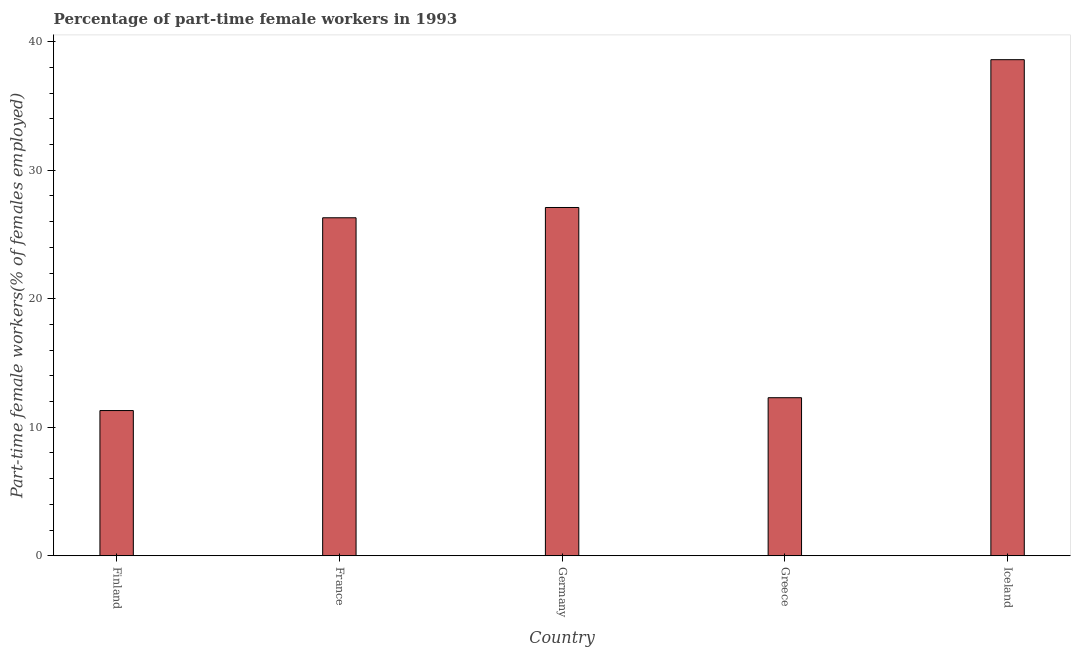Does the graph contain any zero values?
Your answer should be very brief. No. Does the graph contain grids?
Your response must be concise. No. What is the title of the graph?
Provide a succinct answer. Percentage of part-time female workers in 1993. What is the label or title of the X-axis?
Keep it short and to the point. Country. What is the label or title of the Y-axis?
Offer a very short reply. Part-time female workers(% of females employed). What is the percentage of part-time female workers in Greece?
Provide a succinct answer. 12.3. Across all countries, what is the maximum percentage of part-time female workers?
Keep it short and to the point. 38.6. Across all countries, what is the minimum percentage of part-time female workers?
Give a very brief answer. 11.3. In which country was the percentage of part-time female workers maximum?
Keep it short and to the point. Iceland. In which country was the percentage of part-time female workers minimum?
Offer a very short reply. Finland. What is the sum of the percentage of part-time female workers?
Offer a very short reply. 115.6. What is the average percentage of part-time female workers per country?
Give a very brief answer. 23.12. What is the median percentage of part-time female workers?
Give a very brief answer. 26.3. What is the ratio of the percentage of part-time female workers in France to that in Iceland?
Your response must be concise. 0.68. Is the percentage of part-time female workers in Finland less than that in Germany?
Your answer should be compact. Yes. Is the difference between the percentage of part-time female workers in Finland and Germany greater than the difference between any two countries?
Ensure brevity in your answer.  No. Is the sum of the percentage of part-time female workers in France and Germany greater than the maximum percentage of part-time female workers across all countries?
Give a very brief answer. Yes. What is the difference between the highest and the lowest percentage of part-time female workers?
Make the answer very short. 27.3. In how many countries, is the percentage of part-time female workers greater than the average percentage of part-time female workers taken over all countries?
Your answer should be very brief. 3. How many bars are there?
Your answer should be compact. 5. What is the difference between two consecutive major ticks on the Y-axis?
Give a very brief answer. 10. What is the Part-time female workers(% of females employed) of Finland?
Your answer should be compact. 11.3. What is the Part-time female workers(% of females employed) in France?
Your answer should be compact. 26.3. What is the Part-time female workers(% of females employed) of Germany?
Make the answer very short. 27.1. What is the Part-time female workers(% of females employed) of Greece?
Your answer should be compact. 12.3. What is the Part-time female workers(% of females employed) in Iceland?
Offer a terse response. 38.6. What is the difference between the Part-time female workers(% of females employed) in Finland and Germany?
Ensure brevity in your answer.  -15.8. What is the difference between the Part-time female workers(% of females employed) in Finland and Iceland?
Your answer should be very brief. -27.3. What is the difference between the Part-time female workers(% of females employed) in France and Iceland?
Provide a short and direct response. -12.3. What is the difference between the Part-time female workers(% of females employed) in Germany and Greece?
Your response must be concise. 14.8. What is the difference between the Part-time female workers(% of females employed) in Greece and Iceland?
Give a very brief answer. -26.3. What is the ratio of the Part-time female workers(% of females employed) in Finland to that in France?
Give a very brief answer. 0.43. What is the ratio of the Part-time female workers(% of females employed) in Finland to that in Germany?
Ensure brevity in your answer.  0.42. What is the ratio of the Part-time female workers(% of females employed) in Finland to that in Greece?
Your response must be concise. 0.92. What is the ratio of the Part-time female workers(% of females employed) in Finland to that in Iceland?
Offer a very short reply. 0.29. What is the ratio of the Part-time female workers(% of females employed) in France to that in Germany?
Your answer should be compact. 0.97. What is the ratio of the Part-time female workers(% of females employed) in France to that in Greece?
Your response must be concise. 2.14. What is the ratio of the Part-time female workers(% of females employed) in France to that in Iceland?
Offer a terse response. 0.68. What is the ratio of the Part-time female workers(% of females employed) in Germany to that in Greece?
Give a very brief answer. 2.2. What is the ratio of the Part-time female workers(% of females employed) in Germany to that in Iceland?
Provide a succinct answer. 0.7. What is the ratio of the Part-time female workers(% of females employed) in Greece to that in Iceland?
Give a very brief answer. 0.32. 